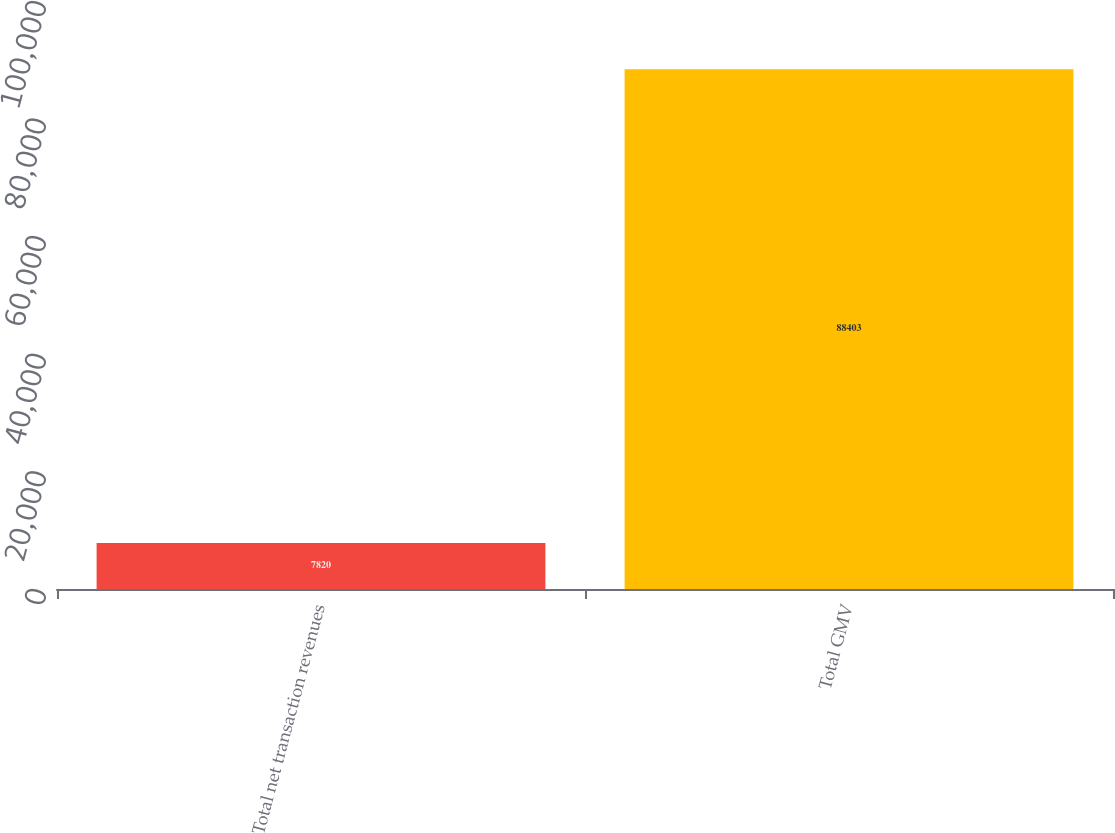Convert chart to OTSL. <chart><loc_0><loc_0><loc_500><loc_500><bar_chart><fcel>Total net transaction revenues<fcel>Total GMV<nl><fcel>7820<fcel>88403<nl></chart> 